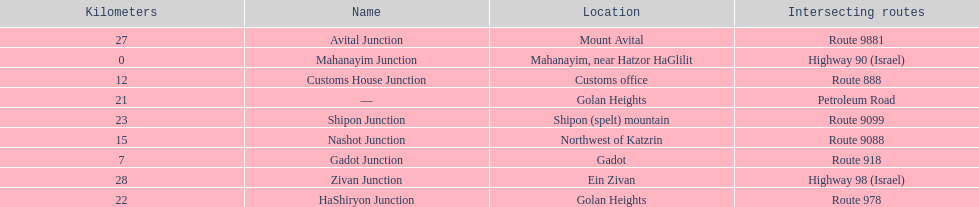How many kilometers away is shipon junction? 23. How many kilometers away is avital junction? 27. Which one is closer to nashot junction? Shipon Junction. 